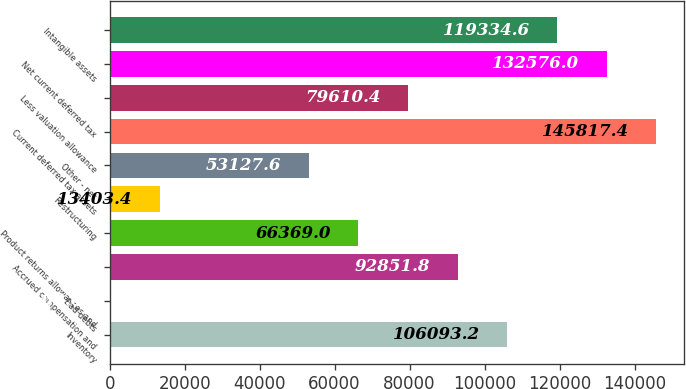<chart> <loc_0><loc_0><loc_500><loc_500><bar_chart><fcel>Inventory<fcel>Bad debts<fcel>Accrued compensation and<fcel>Product returns allowances and<fcel>Restructuring<fcel>Other - net<fcel>Current deferred tax assets<fcel>Less valuation allowance<fcel>Net current deferred tax<fcel>Intangible assets<nl><fcel>106093<fcel>162<fcel>92851.8<fcel>66369<fcel>13403.4<fcel>53127.6<fcel>145817<fcel>79610.4<fcel>132576<fcel>119335<nl></chart> 